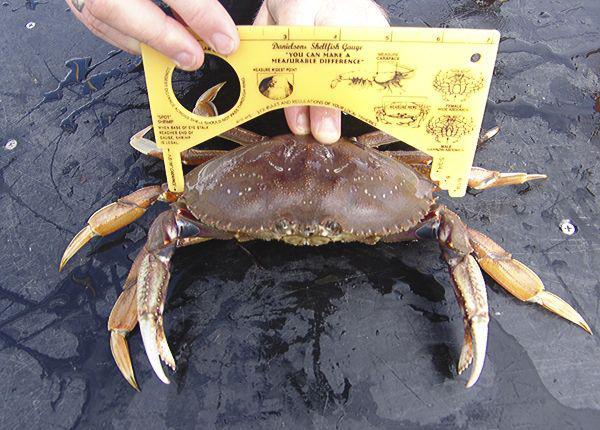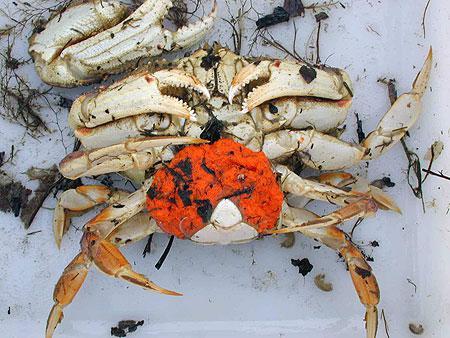The first image is the image on the left, the second image is the image on the right. Given the left and right images, does the statement "A person is touching the crab in the image on the left." hold true? Answer yes or no. Yes. 